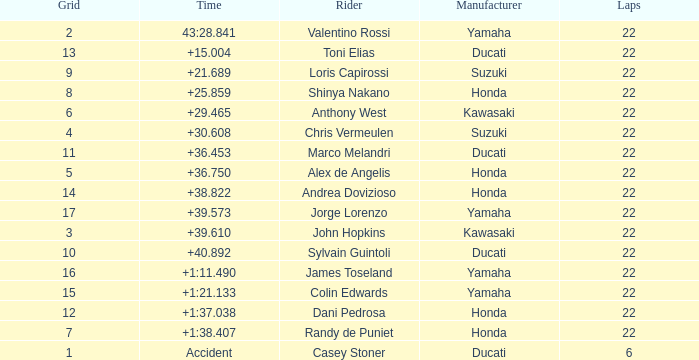Who had the lowest laps on a grid smaller than 16 with a time of +21.689? 22.0. 